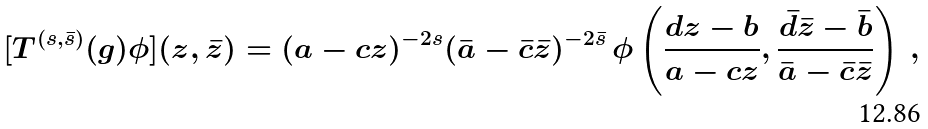Convert formula to latex. <formula><loc_0><loc_0><loc_500><loc_500>[ T ^ { ( s , \bar { s } ) } ( g ) \phi ] ( z , \bar { z } ) = ( a - c z ) ^ { - 2 s } ( \bar { a } - \bar { c } \bar { z } ) ^ { - 2 \bar { s } } \, \phi \left ( \frac { d z - b } { a - c z } , \frac { \bar { d } \bar { z } - \bar { b } } { \bar { a } - \bar { c } \bar { z } } \right ) \, ,</formula> 